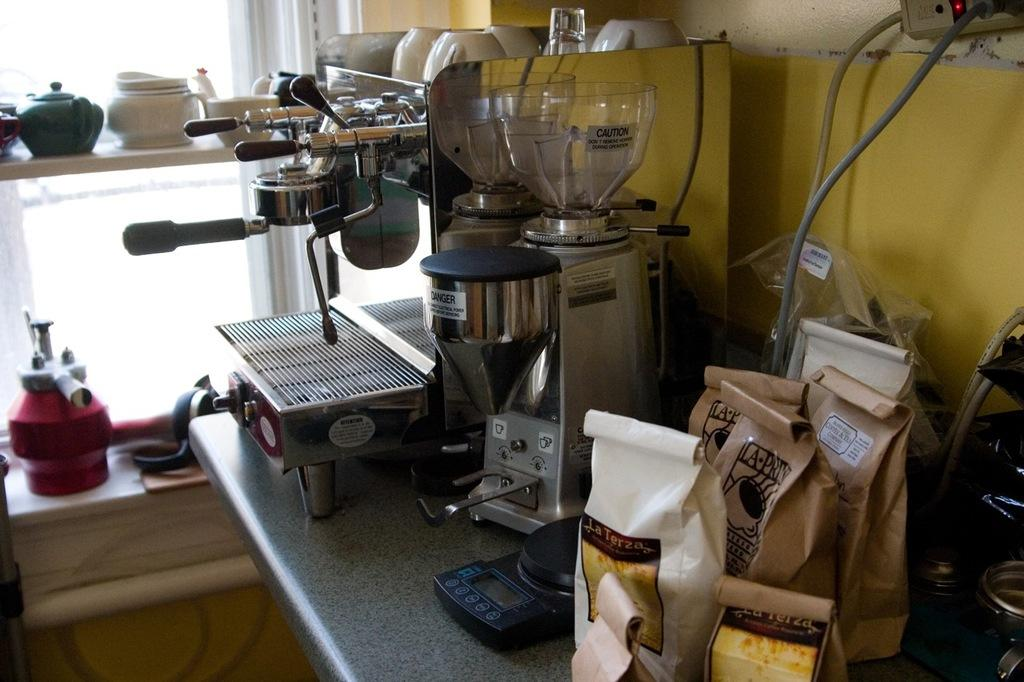<image>
Present a compact description of the photo's key features. A white bag with La Terza sits on a table next to coffee makers. 